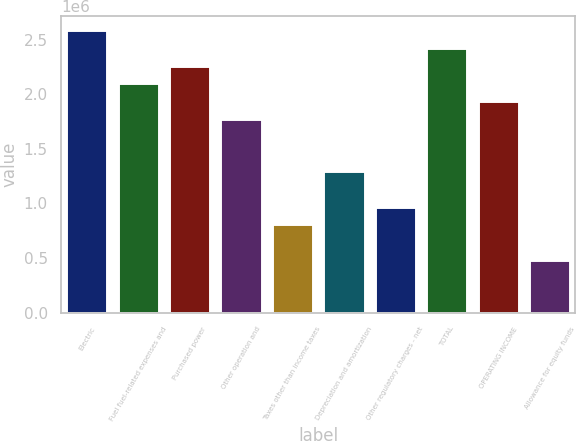Convert chart. <chart><loc_0><loc_0><loc_500><loc_500><bar_chart><fcel>Electric<fcel>Fuel fuel-related expenses and<fcel>Purchased power<fcel>Other operation and<fcel>Taxes other than income taxes<fcel>Depreciation and amortization<fcel>Other regulatory charges - net<fcel>TOTAL<fcel>OPERATING INCOME<fcel>Allowance for equity funds<nl><fcel>2.58454e+06<fcel>2.10008e+06<fcel>2.26157e+06<fcel>1.77711e+06<fcel>808182<fcel>1.29264e+06<fcel>969670<fcel>2.42306e+06<fcel>1.93859e+06<fcel>485208<nl></chart> 